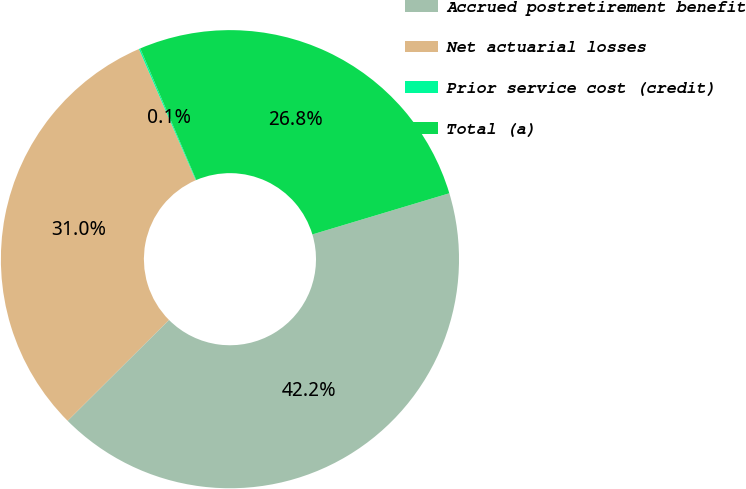<chart> <loc_0><loc_0><loc_500><loc_500><pie_chart><fcel>Accrued postretirement benefit<fcel>Net actuarial losses<fcel>Prior service cost (credit)<fcel>Total (a)<nl><fcel>42.18%<fcel>30.96%<fcel>0.1%<fcel>26.76%<nl></chart> 